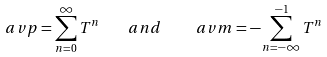<formula> <loc_0><loc_0><loc_500><loc_500>\ a v p = \sum _ { n = 0 } ^ { \infty } T ^ { n } \quad a n d \quad \ a v m = - \sum _ { n = - \infty } ^ { - 1 } T ^ { n }</formula> 